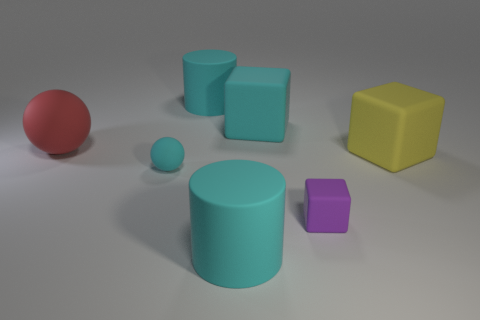Add 2 large rubber blocks. How many objects exist? 9 Subtract all spheres. How many objects are left? 5 Add 6 cylinders. How many cylinders exist? 8 Subtract 0 brown cubes. How many objects are left? 7 Subtract all small brown rubber spheres. Subtract all large red things. How many objects are left? 6 Add 7 red matte things. How many red matte things are left? 8 